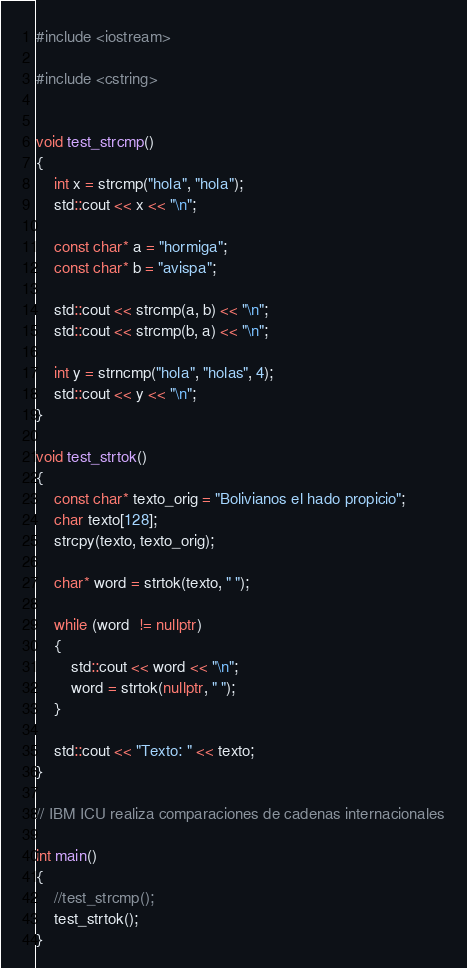<code> <loc_0><loc_0><loc_500><loc_500><_C++_>#include <iostream>

#include <cstring>


void test_strcmp()
{
	int x = strcmp("hola", "hola");
	std::cout << x << "\n";
	
	const char* a = "hormiga";
	const char* b = "avispa";
	
	std::cout << strcmp(a, b) << "\n";
	std::cout << strcmp(b, a) << "\n";
	
	int y = strncmp("hola", "holas", 4);
	std::cout << y << "\n";
}

void test_strtok()
{
	const char* texto_orig = "Bolivianos el hado propicio";
	char texto[128];
	strcpy(texto, texto_orig);
	
	char* word = strtok(texto, " ");
	
	while (word  != nullptr)
	{
		std::cout << word << "\n";
		word = strtok(nullptr, " ");
	}
	
	std::cout << "Texto: " << texto;
}

// IBM ICU realiza comparaciones de cadenas internacionales

int main()
{
	//test_strcmp();
	test_strtok();
}
</code> 